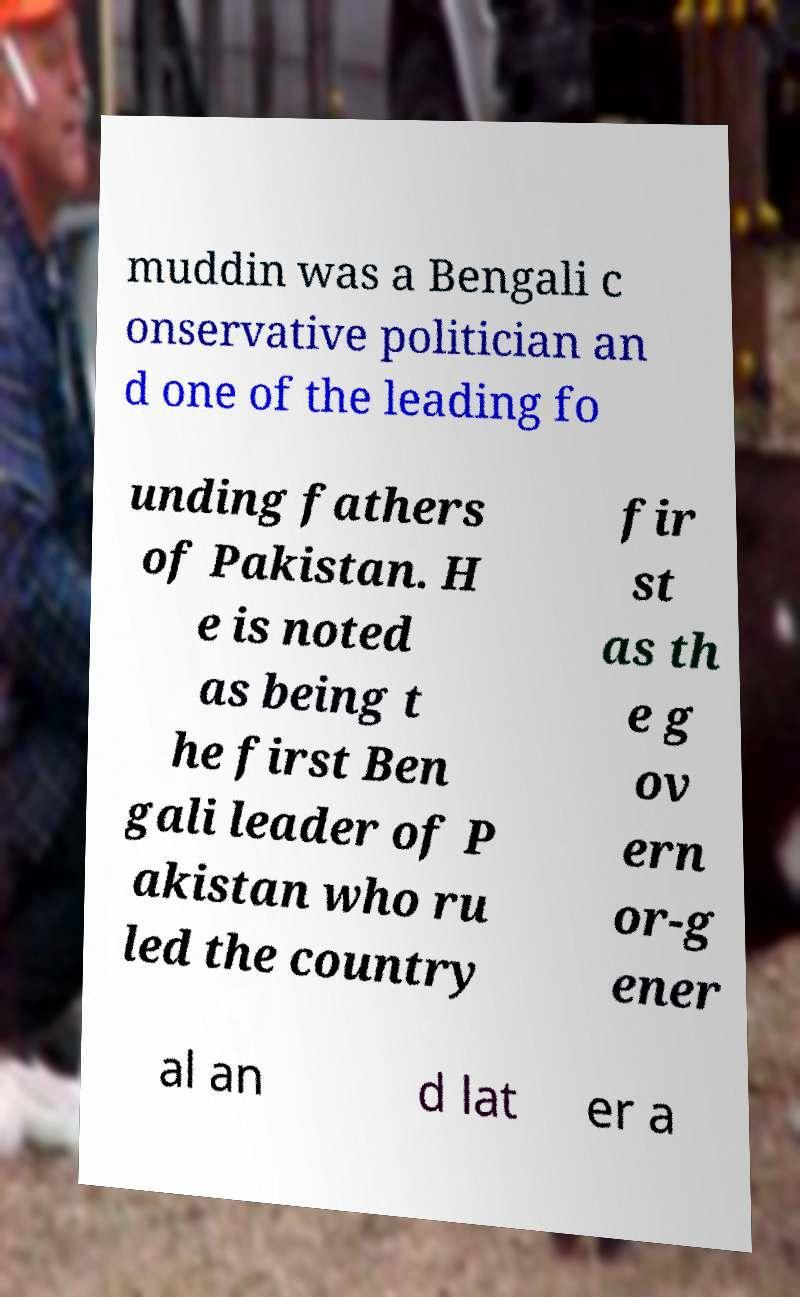Could you extract and type out the text from this image? muddin was a Bengali c onservative politician an d one of the leading fo unding fathers of Pakistan. H e is noted as being t he first Ben gali leader of P akistan who ru led the country fir st as th e g ov ern or-g ener al an d lat er a 